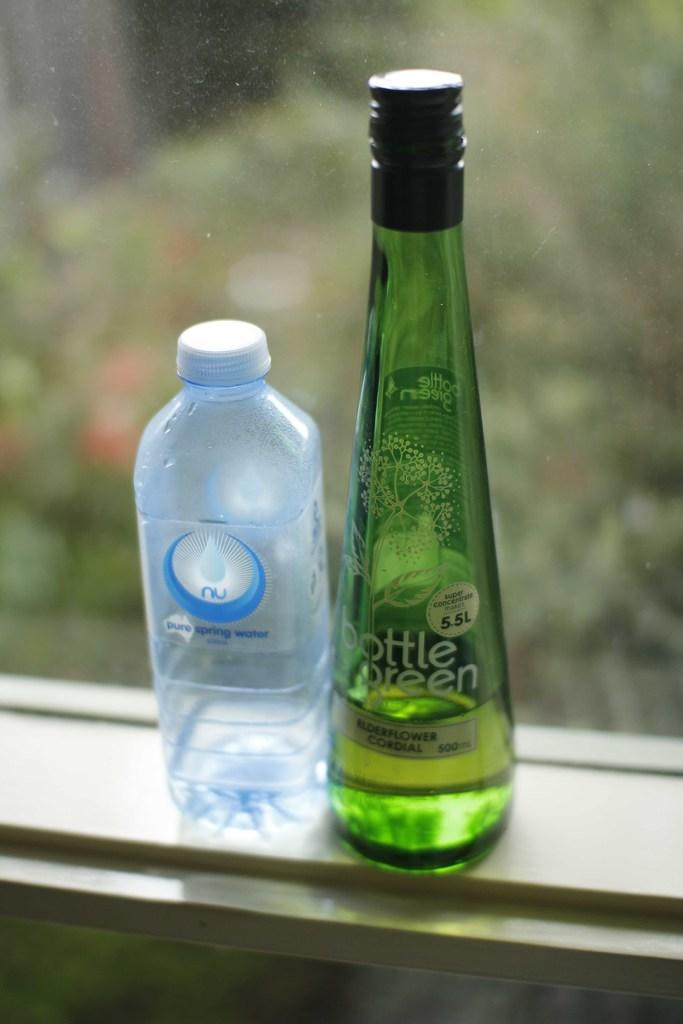What colors are the bottles in the image? There is a green color bottle and a blue color bottle in the image. Can you describe the appearance of the bottles? The bottles are of different colors, with one being green and the other being blue. What type of guitar is being played in the image? There is no guitar present in the image; it only features two bottles of different colors. How does the needle affect the income of the person in the image? There is no needle or income mentioned in the image, as it only features two bottles of different colors. 